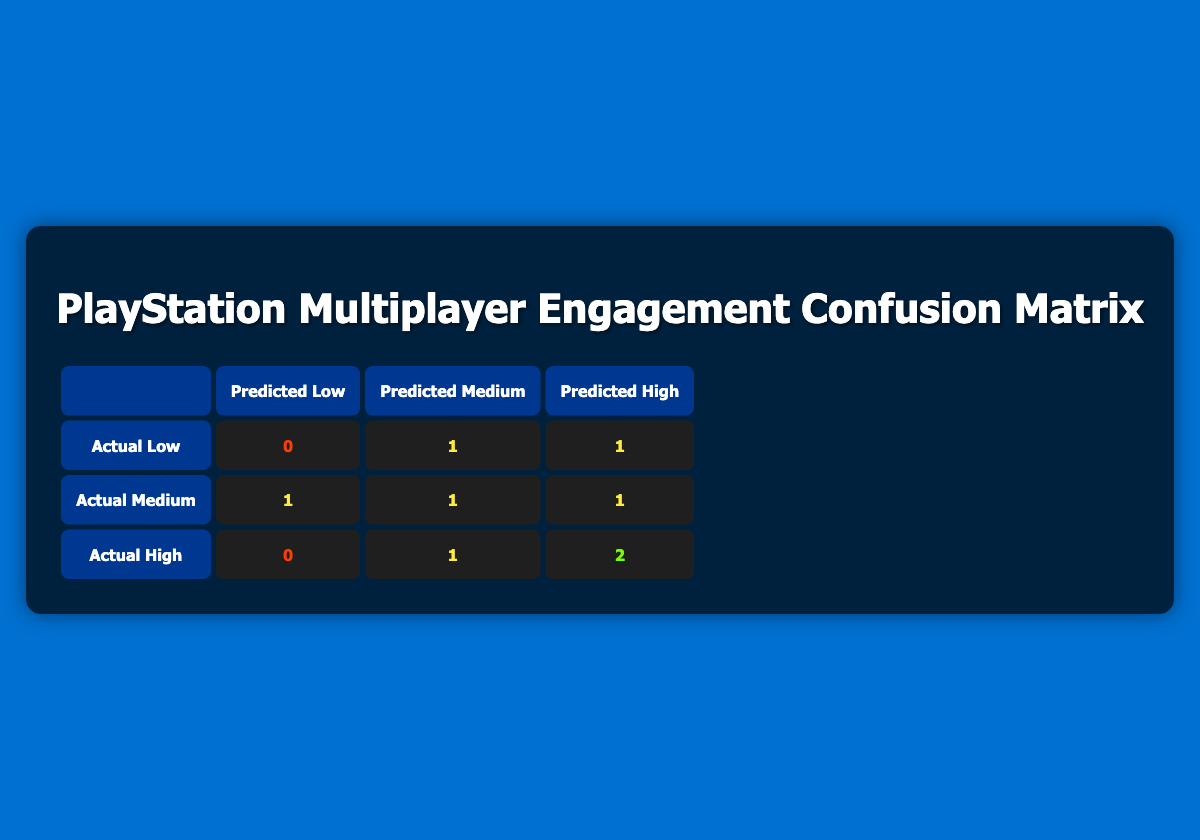What is the number of times the actual engagement was high? To find the number of times the actual engagement was high, we look at the 'Actual High' row in the matrix. The entries under this row show counts for different predicted engagement categories. The counts are: Predicted Low: 0, Predicted Medium: 1, Predicted High: 2. Thus, summing these counts gives us 0 + 1 + 2 = 3.
Answer: 3 How many games were predicted to have low engagement? To find out how many games were predicted to have low engagement, we look at the 'Predicted Low' column. We see there are entries under the 'Actual Low,' 'Actual Medium,' and 'Actual High' rows. The counts are: Actual Low: 0, Actual Medium: 1, Actual High: 0. Summing these gives us 0 + 1 + 0 = 1.
Answer: 1 Is there any game that was predicted as high but had an actual engagement of low? We need to see if there's any entry where 'Predicted High' has a corresponding 'Actual Low' entry. Looking at the table, under 'Actual Low,' the 'Predicted High' count is 1, which indicates that there is indeed one instance where this is true.
Answer: Yes What is the total number of games with actual medium engagement? To find this, we look at the 'Actual Medium' row, which shows counts for the keys predicted engagement. The entry counts are: Predicted Low: 1, Predicted Medium: 1, Predicted High: 1. Summing these counts gives us 1 + 1 + 1 = 3.
Answer: 3 How many more actual games were there classified as high than low engagement? To find this difference, we compare the totals from 'Actual High' and 'Actual Low' rows. 'Actual High' has counts of 0 + 1 + 2 = 3, while 'Actual Low' has counts of 0 + 1 + 1 = 2. Thus we calculate 3 - 2 = 1.
Answer: 1 